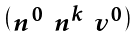<formula> <loc_0><loc_0><loc_500><loc_500>\begin{psmallmatrix} n ^ { 0 } & n ^ { k } & v ^ { 0 } \end{psmallmatrix}</formula> 